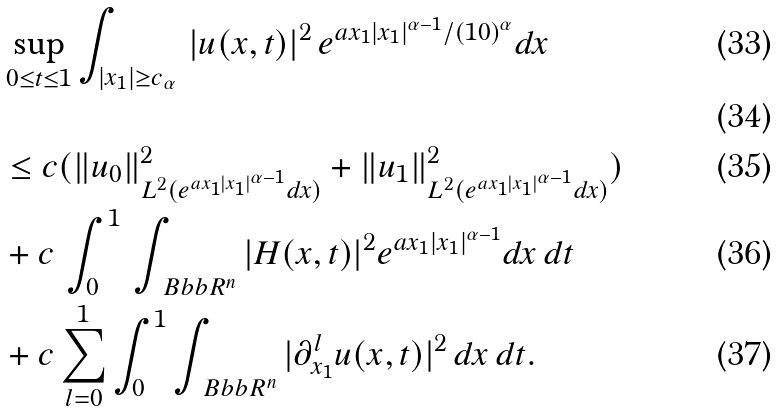<formula> <loc_0><loc_0><loc_500><loc_500>& \sup _ { 0 \leq t \leq 1 } \int _ { | x _ { 1 } | \geq c _ { \alpha } } \, | u ( x , t ) | ^ { 2 } \, e ^ { a x _ { 1 } | x _ { 1 } | ^ { \alpha - 1 } / ( 1 0 ) ^ { \alpha } } d x \\ \\ & \leq c ( \| u _ { 0 } \| ^ { 2 } _ { L ^ { 2 } ( e ^ { a x _ { 1 } | x _ { 1 } | ^ { \alpha - 1 } } d x ) } + \| u _ { 1 } \| ^ { 2 } _ { L ^ { 2 } ( e ^ { a x _ { 1 } | x _ { 1 } | ^ { \alpha - 1 } } d x ) } ) \\ & + c \, \int _ { 0 } ^ { 1 } \, \int _ { \ B b b R ^ { n } } | H ( x , t ) | ^ { 2 } e ^ { a x _ { 1 } | x _ { 1 } | ^ { \alpha - 1 } } d x \, d t \\ & + c \sum _ { l = 0 } ^ { 1 } \int _ { 0 } ^ { 1 } \int _ { \ B b b R ^ { n } } | \partial ^ { l } _ { x _ { 1 } } u ( x , t ) | ^ { 2 } \, d x \, d t .</formula> 